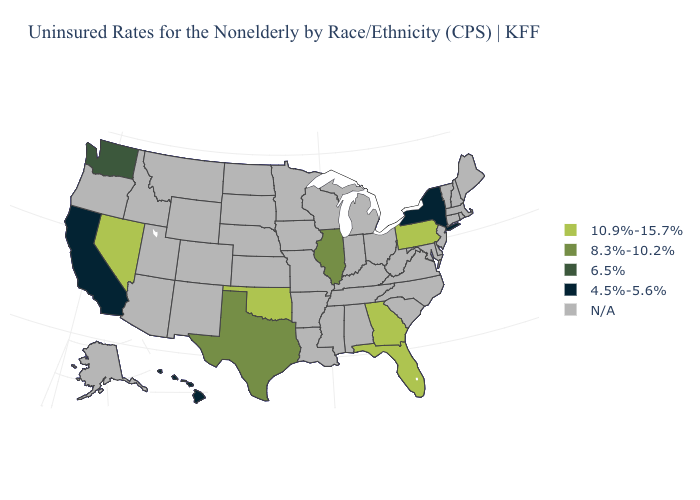Name the states that have a value in the range N/A?
Quick response, please. Alabama, Alaska, Arizona, Arkansas, Colorado, Connecticut, Delaware, Idaho, Indiana, Iowa, Kansas, Kentucky, Louisiana, Maine, Maryland, Massachusetts, Michigan, Minnesota, Mississippi, Missouri, Montana, Nebraska, New Hampshire, New Jersey, New Mexico, North Carolina, North Dakota, Ohio, Oregon, Rhode Island, South Carolina, South Dakota, Tennessee, Utah, Vermont, Virginia, West Virginia, Wisconsin, Wyoming. What is the value of Tennessee?
Write a very short answer. N/A. Which states hav the highest value in the South?
Short answer required. Florida, Georgia, Oklahoma. Does New York have the highest value in the USA?
Be succinct. No. Which states hav the highest value in the South?
Short answer required. Florida, Georgia, Oklahoma. Which states hav the highest value in the West?
Give a very brief answer. Nevada. Which states have the highest value in the USA?
Concise answer only. Florida, Georgia, Nevada, Oklahoma, Pennsylvania. Among the states that border Kentucky , which have the lowest value?
Quick response, please. Illinois. Name the states that have a value in the range 10.9%-15.7%?
Quick response, please. Florida, Georgia, Nevada, Oklahoma, Pennsylvania. Does New York have the highest value in the USA?
Give a very brief answer. No. Name the states that have a value in the range N/A?
Keep it brief. Alabama, Alaska, Arizona, Arkansas, Colorado, Connecticut, Delaware, Idaho, Indiana, Iowa, Kansas, Kentucky, Louisiana, Maine, Maryland, Massachusetts, Michigan, Minnesota, Mississippi, Missouri, Montana, Nebraska, New Hampshire, New Jersey, New Mexico, North Carolina, North Dakota, Ohio, Oregon, Rhode Island, South Carolina, South Dakota, Tennessee, Utah, Vermont, Virginia, West Virginia, Wisconsin, Wyoming. Which states have the lowest value in the USA?
Quick response, please. California, Hawaii, New York. Which states have the lowest value in the South?
Quick response, please. Texas. What is the value of Arkansas?
Quick response, please. N/A. 